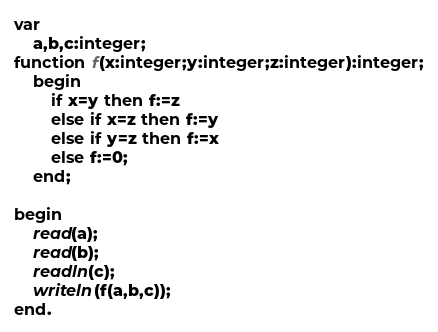Convert code to text. <code><loc_0><loc_0><loc_500><loc_500><_Pascal_>var
    a,b,c:integer;
function f(x:integer;y:integer;z:integer):integer;
    begin
        if x=y then f:=z
        else if x=z then f:=y
        else if y=z then f:=x
        else f:=0;
    end;
    
begin
    read(a);
    read(b);
    readln(c);
    writeln(f(a,b,c));
end.</code> 